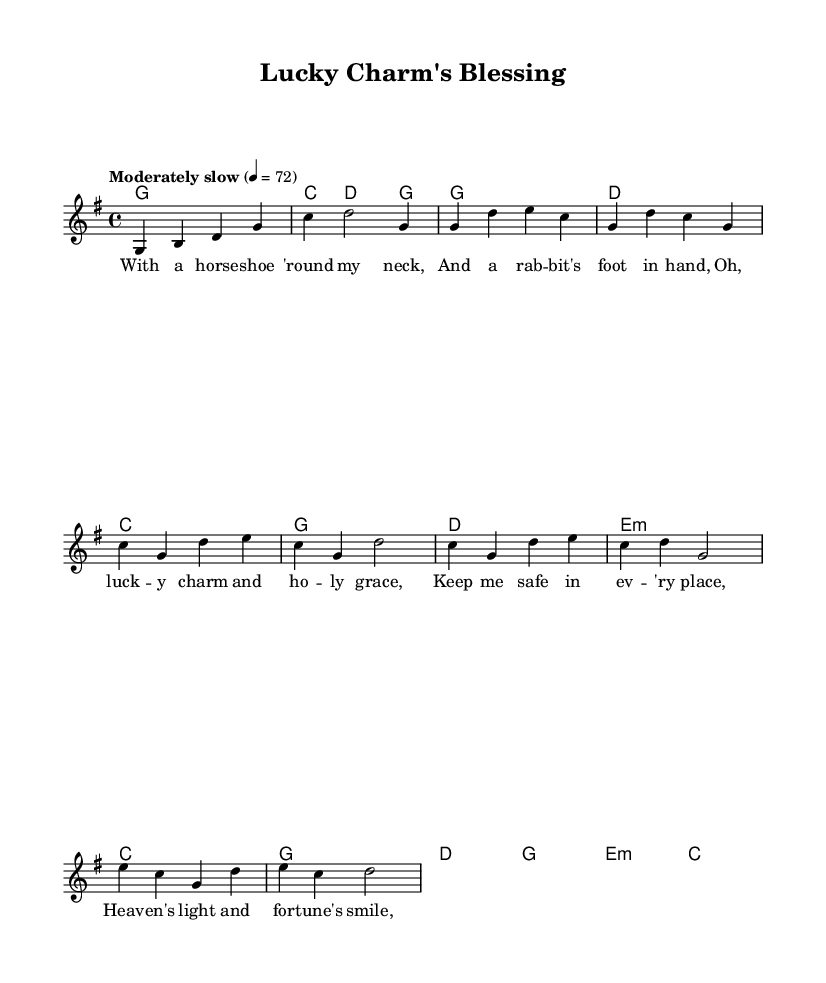What is the key signature of this music? The key signature is G major, which has one sharp (F#). This can be determined by looking at the key indicated after the "global" section.
Answer: G major What is the time signature of this music? The time signature is 4/4, which indicates four beats in each measure and the quarter note gets one beat. This is found after the key signature in the "global" section.
Answer: 4/4 What is the tempo marking for this piece? The tempo marking is "Moderately slow", which indicates the performance speed. It is mentioned in the tempo instruction within the "global" section.
Answer: Moderately slow How many measures are in the chorus? The chorus consists of four measures, which is evident when counting the grouped notes and rests in that section.
Answer: Four What kind of harmony is used in the bridge? The bridge uses minor harmony as indicated by the e minor chord found in the harmonies section of the score. This contributes to the darker tone of that part.
Answer: Minor Which lucky charm is mentioned in the first verse? The first verse mentions a "horse shoe", which is a popular superstition for good luck. This can be found in the lyric part corresponding to the melody.
Answer: Horse shoe What is the central theme of the lyrics? The central theme is divine protection and the integration of luck with faith, as seen in the repeated mentions of "lucky charm" and "God" throughout the lyrics.
Answer: Divine protection and luck 